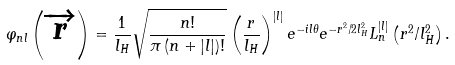Convert formula to latex. <formula><loc_0><loc_0><loc_500><loc_500>\varphi _ { n l } \left ( \overrightarrow { r } \right ) = \frac { 1 } { l _ { H } } \sqrt { \frac { n ! } { \pi \left ( n + | l | \right ) ! } } \left ( \frac { r } { l _ { H } } \right ) ^ { | l | } e ^ { - i l \theta } e ^ { - r ^ { 2 } / { 2 l _ { H } ^ { 2 } } } L _ { n } ^ { | l | } \left ( r ^ { 2 } / l _ { H } ^ { 2 } \right ) .</formula> 